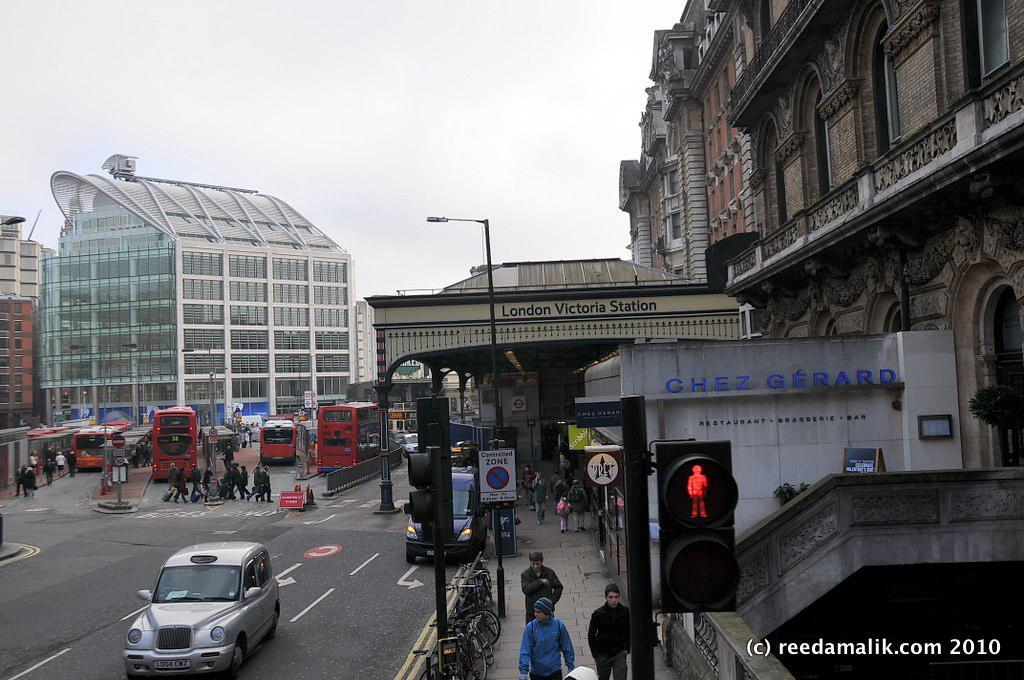<image>
Present a compact description of the photo's key features. The London Victoria Station has a restaurant in front of it called Chez Gerard. 